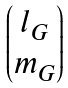Convert formula to latex. <formula><loc_0><loc_0><loc_500><loc_500>\begin{pmatrix} l _ { G } \\ m _ { G } \end{pmatrix}</formula> 